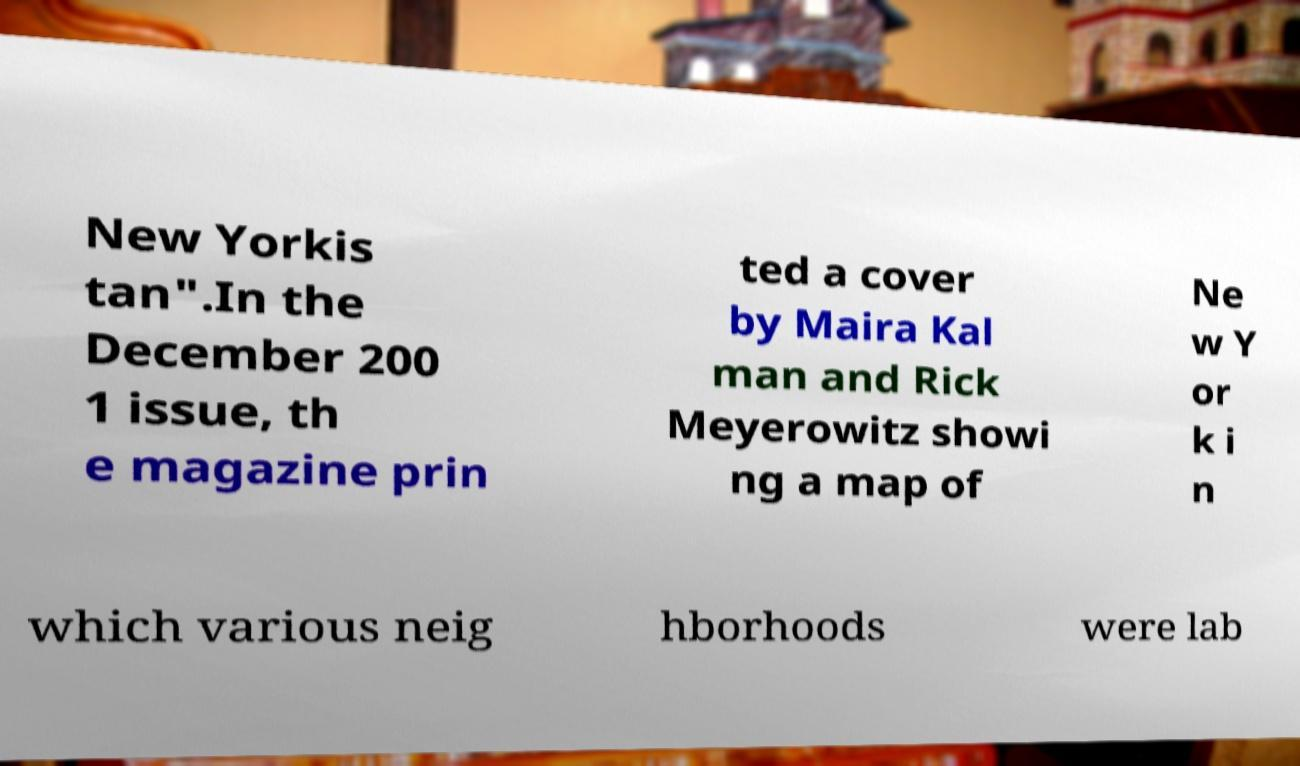Could you extract and type out the text from this image? New Yorkis tan".In the December 200 1 issue, th e magazine prin ted a cover by Maira Kal man and Rick Meyerowitz showi ng a map of Ne w Y or k i n which various neig hborhoods were lab 